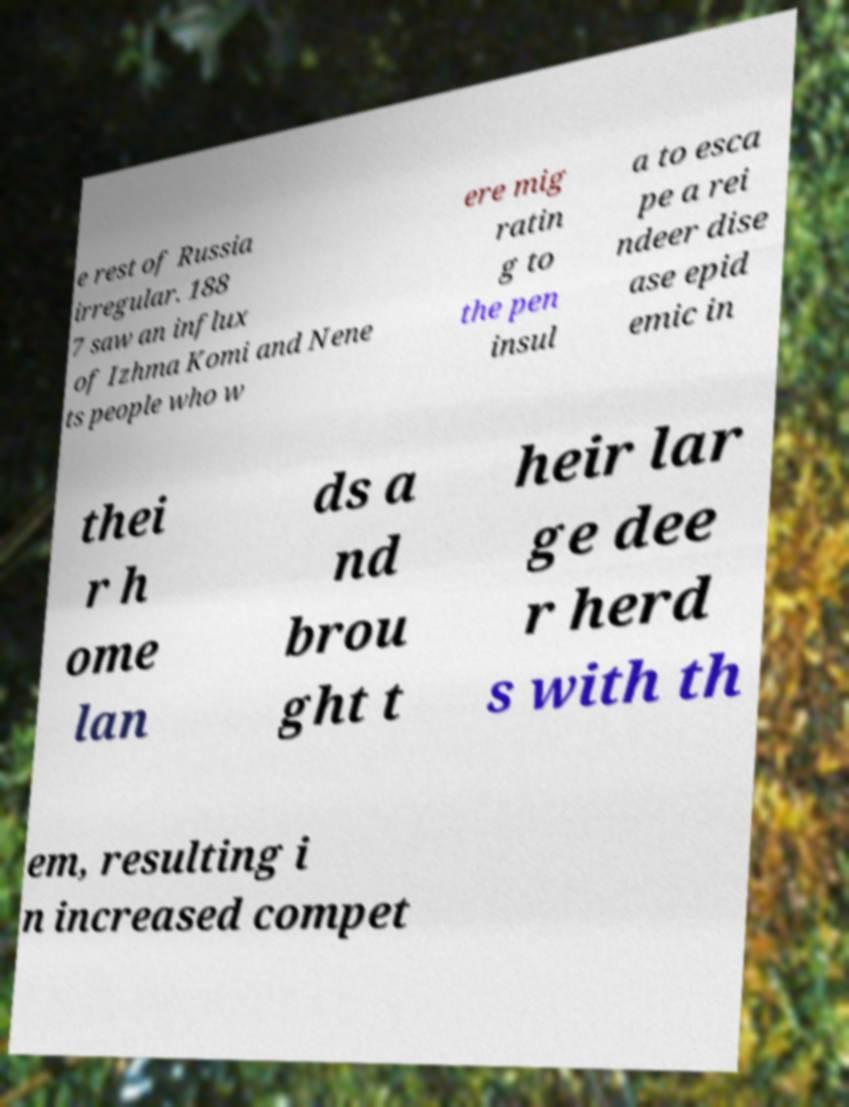I need the written content from this picture converted into text. Can you do that? e rest of Russia irregular. 188 7 saw an influx of Izhma Komi and Nene ts people who w ere mig ratin g to the pen insul a to esca pe a rei ndeer dise ase epid emic in thei r h ome lan ds a nd brou ght t heir lar ge dee r herd s with th em, resulting i n increased compet 